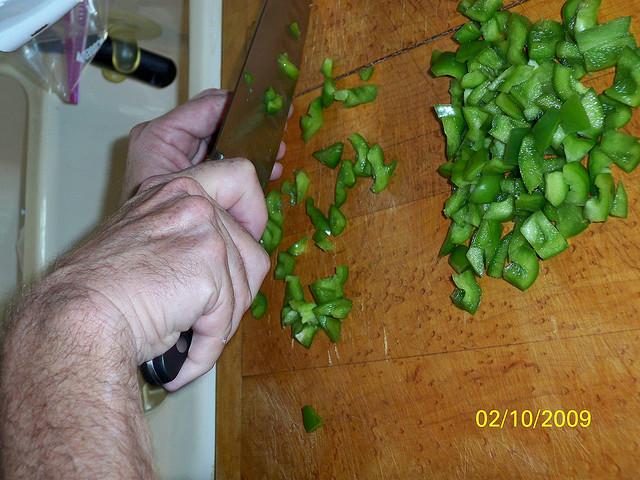What is this person cutting with a knife?
Be succinct. Peppers. What is the time stamp on the photo?
Keep it brief. 02/10/2009. Is which hand is he holding the knife?
Short answer required. Right. 